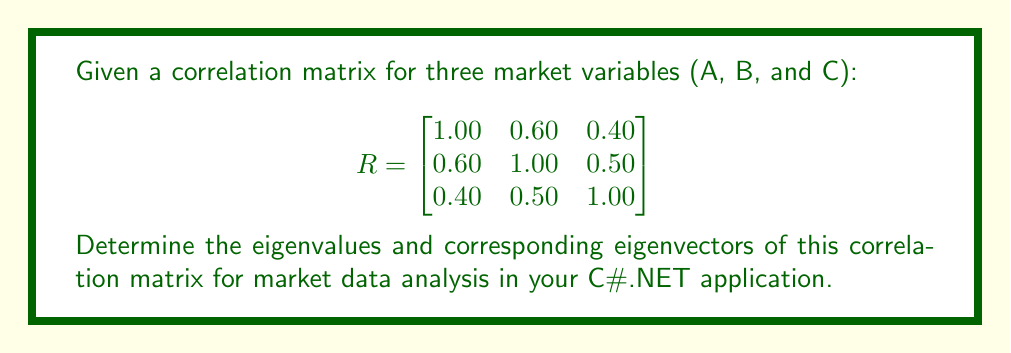Show me your answer to this math problem. To find the eigenvalues and eigenvectors of the correlation matrix R, we follow these steps:

1. Find the eigenvalues by solving the characteristic equation:
   $$\det(R - \lambda I) = 0$$

2. Expand the determinant:
   $$\begin{vmatrix}
   1-\lambda & 0.60 & 0.40 \\
   0.60 & 1-\lambda & 0.50 \\
   0.40 & 0.50 & 1-\lambda
   \end{vmatrix} = 0$$

3. Solve the resulting cubic equation:
   $$(1-\lambda)^3 - 0.36(1-\lambda) - 0.16(1-\lambda) - 0.25(1-\lambda) - 0.12 = 0$$
   $$-\lambda^3 + 3\lambda^2 - 2.23\lambda + 0.27 = 0$$

4. The roots of this equation are the eigenvalues:
   $$\lambda_1 \approx 2.0855, \lambda_2 \approx 0.5797, \lambda_3 \approx 0.3348$$

5. For each eigenvalue, find the corresponding eigenvector by solving:
   $$(R - \lambda_i I)v_i = 0$$

6. For $\lambda_1 \approx 2.0855$:
   $$\begin{bmatrix}
   -1.0855 & 0.60 & 0.40 \\
   0.60 & -1.0855 & 0.50 \\
   0.40 & 0.50 & -1.0855
   \end{bmatrix}\begin{bmatrix}
   v_{11} \\ v_{12} \\ v_{13}
   \end{bmatrix} = \begin{bmatrix}
   0 \\ 0 \\ 0
   \end{bmatrix}$$

   Solving this system gives: $v_1 \approx [0.5774, 0.6268, 0.5230]^T$

7. Similarly, for $\lambda_2 \approx 0.5797$ and $\lambda_3 \approx 0.3348$, we get:
   $v_2 \approx [-0.7071, 0, 0.7071]^T$
   $v_3 \approx [-0.4082, 0.8165, -0.4082]^T$

8. Normalize the eigenvectors to unit length.

These eigenvalues and eigenvectors can be used in your C#.NET application for principal component analysis or other market data analysis techniques.
Answer: Eigenvalues: $\lambda_1 \approx 2.0855, \lambda_2 \approx 0.5797, \lambda_3 \approx 0.3348$
Eigenvectors: $v_1 \approx [0.5774, 0.6268, 0.5230]^T, v_2 \approx [-0.7071, 0, 0.7071]^T, v_3 \approx [-0.4082, 0.8165, -0.4082]^T$ 